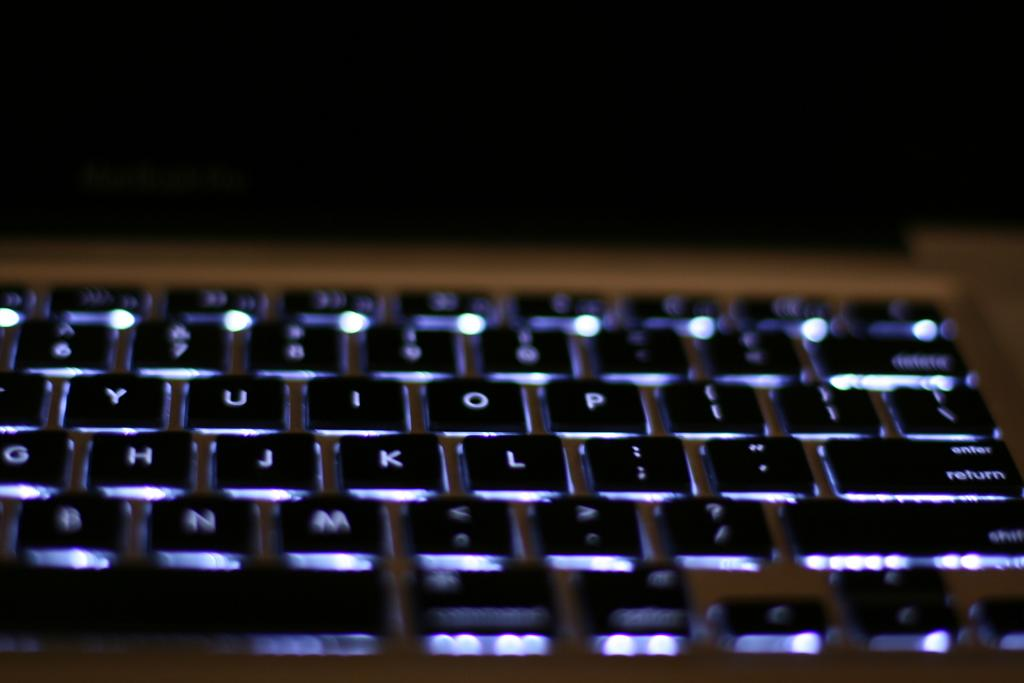<image>
Summarize the visual content of the image. A black keyboard is shown with the letters j, k, l including others. 